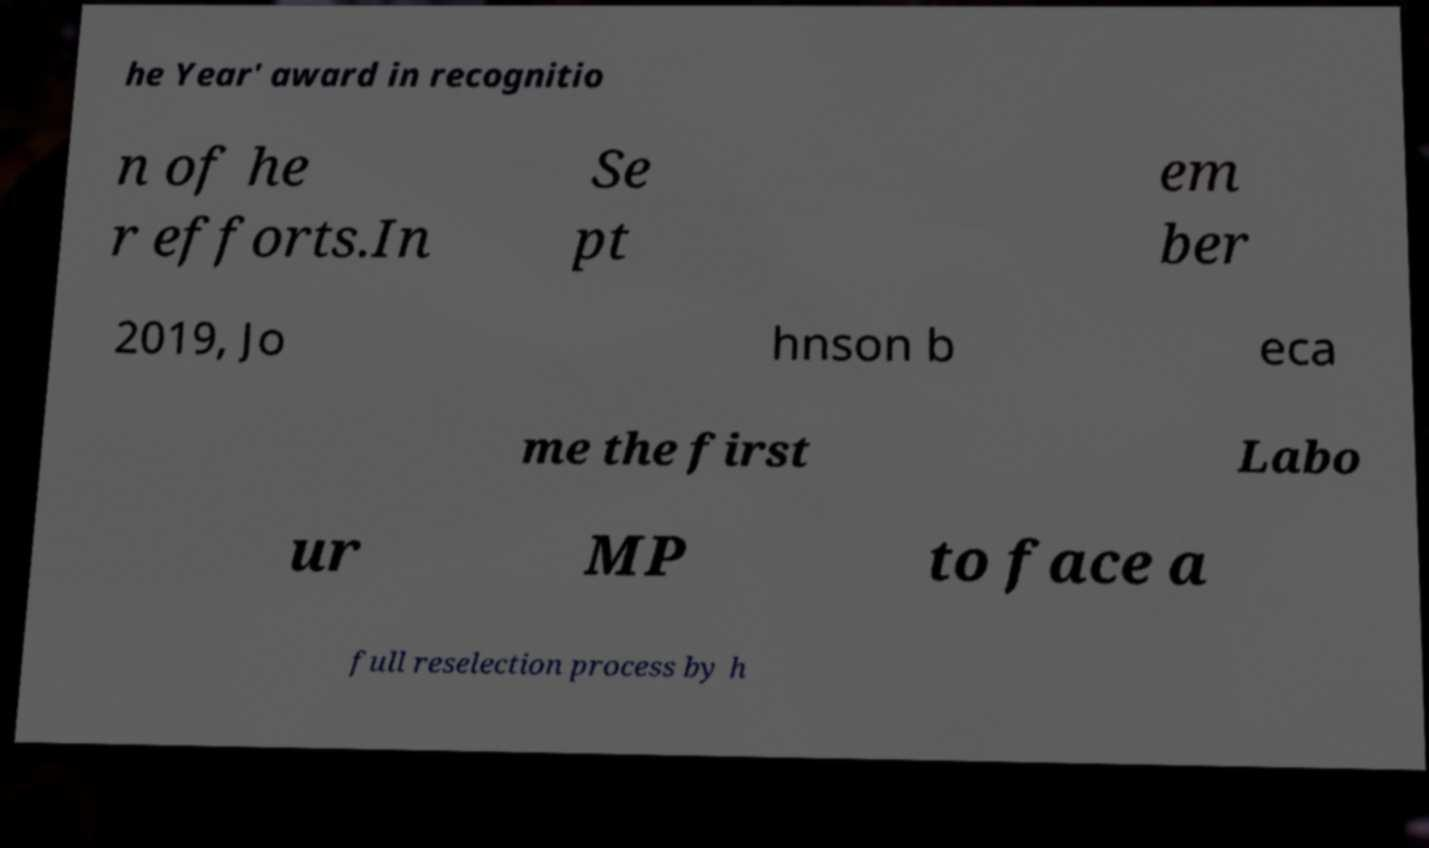Please read and relay the text visible in this image. What does it say? he Year' award in recognitio n of he r efforts.In Se pt em ber 2019, Jo hnson b eca me the first Labo ur MP to face a full reselection process by h 